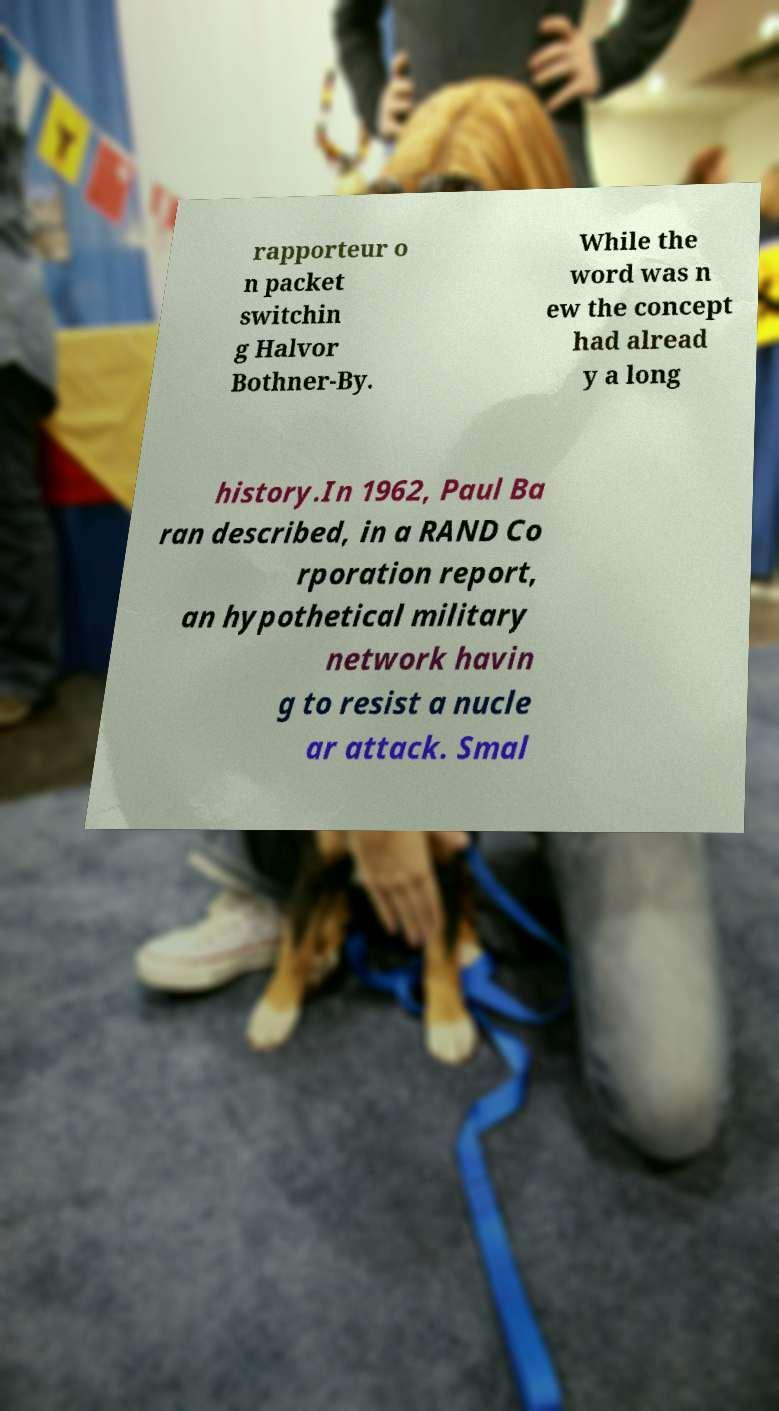I need the written content from this picture converted into text. Can you do that? rapporteur o n packet switchin g Halvor Bothner-By. While the word was n ew the concept had alread y a long history.In 1962, Paul Ba ran described, in a RAND Co rporation report, an hypothetical military network havin g to resist a nucle ar attack. Smal 